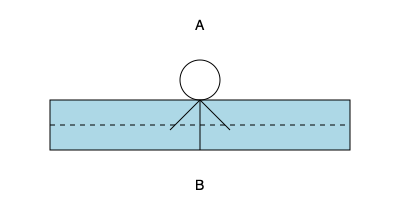In the stick figure illustration above, which body position (A or B) represents the correct posture for a kayaker? To determine the correct body position for a kayaker, let's analyze the illustration step-by-step:

1. The blue rectangle represents the kayak.
2. The dashed line represents the water level.
3. Position A shows the stick figure sitting upright with a straight back.
4. Position B shows the stick figure leaning slightly forward.

The correct posture for a kayaker is position B, and here's why:

1. Forward lean: A slight forward lean helps maintain balance and control of the kayak. It allows for better power transfer when paddling.

2. Lower center of gravity: Leaning forward lowers the kayaker's center of gravity, making the kayak more stable and less likely to tip over.

3. Improved paddle reach: The forward lean position allows for a more extended reach when paddling, increasing efficiency and power in each stroke.

4. Better visibility: Leaning slightly forward provides a better view of the water ahead, which is crucial for navigating obstacles and reading the water.

5. Reduced wind resistance: A lower profile created by leaning forward reduces wind resistance, making it easier to paddle in windy conditions.

6. Improved readiness: This position keeps the kayaker ready to react quickly to changes in water conditions or to brace against waves.

In contrast, position A (sitting upright) is less ideal because:
- It raises the center of gravity, making the kayak less stable.
- It reduces the power and efficiency of paddle strokes.
- It increases wind resistance.
- It may cause more strain on the lower back over long periods.
Answer: B 